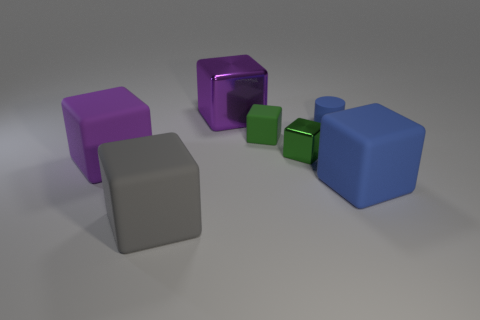How many balls are either yellow matte things or big gray matte objects?
Keep it short and to the point. 0. What is the shape of the big rubber object to the right of the large gray matte block?
Offer a terse response. Cube. How many tiny red balls have the same material as the large blue block?
Give a very brief answer. 0. Is the number of green matte objects left of the large gray thing less than the number of red rubber cylinders?
Offer a very short reply. No. There is a object that is in front of the big matte object right of the large gray matte object; what size is it?
Your response must be concise. Large. Is the color of the small matte block the same as the large matte object that is in front of the blue rubber cube?
Ensure brevity in your answer.  No. There is a purple block that is the same size as the purple metal object; what material is it?
Give a very brief answer. Rubber. Are there fewer small blue matte cylinders in front of the gray rubber thing than large purple things that are behind the small green metal object?
Make the answer very short. Yes. There is a purple object behind the big matte object that is on the left side of the gray matte block; what is its shape?
Keep it short and to the point. Cube. Are there any big blue matte objects?
Ensure brevity in your answer.  Yes. 